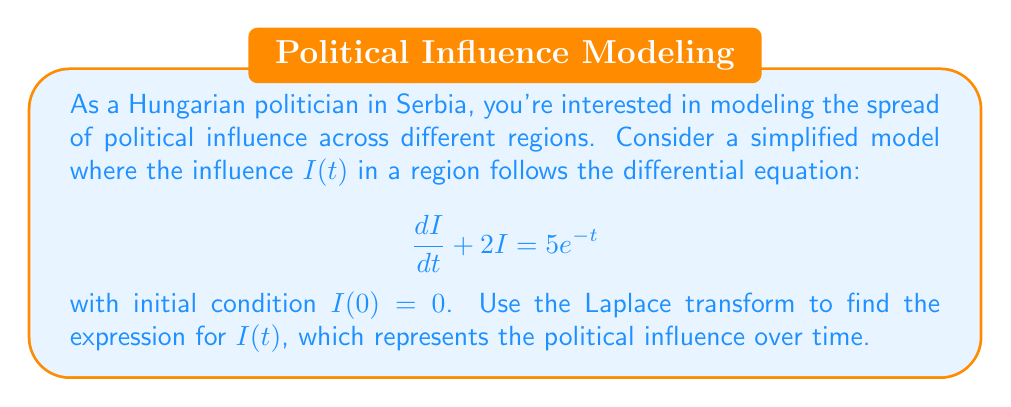Help me with this question. Let's solve this using the Laplace transform method:

1) Take the Laplace transform of both sides of the equation:
   $$\mathcal{L}\{\frac{dI}{dt} + 2I\} = \mathcal{L}\{5e^{-t}\}$$

2) Using Laplace transform properties:
   $$sI(s) - I(0) + 2I(s) = \frac{5}{s+1}$$

3) Substitute the initial condition $I(0) = 0$:
   $$sI(s) + 2I(s) = \frac{5}{s+1}$$

4) Factor out $I(s)$:
   $$I(s)(s + 2) = \frac{5}{s+1}$$

5) Solve for $I(s)$:
   $$I(s) = \frac{5}{(s+1)(s+2)}$$

6) Use partial fraction decomposition:
   $$I(s) = \frac{A}{s+1} + \frac{B}{s+2}$$
   where $A$ and $B$ are constants to be determined.

7) Find $A$ and $B$:
   $$5 = A(s+2) + B(s+1)$$
   When $s = -1$: $5 = A(1) + B(0)$, so $A = 5$
   When $s = -2$: $5 = A(0) + B(-1)$, so $B = -5$

8) Therefore:
   $$I(s) = \frac{5}{s+1} - \frac{5}{s+2}$$

9) Take the inverse Laplace transform:
   $$I(t) = 5e^{-t} - 5e^{-2t}$$

This gives us the expression for political influence over time.
Answer: $I(t) = 5e^{-t} - 5e^{-2t}$ 